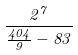Convert formula to latex. <formula><loc_0><loc_0><loc_500><loc_500>\frac { 2 ^ { 7 } } { \frac { 4 0 4 } { 9 } - 8 3 }</formula> 